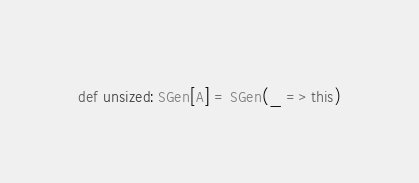Convert code to text. <code><loc_0><loc_0><loc_500><loc_500><_Scala_>def unsized: SGen[A] = SGen(_ => this)</code> 